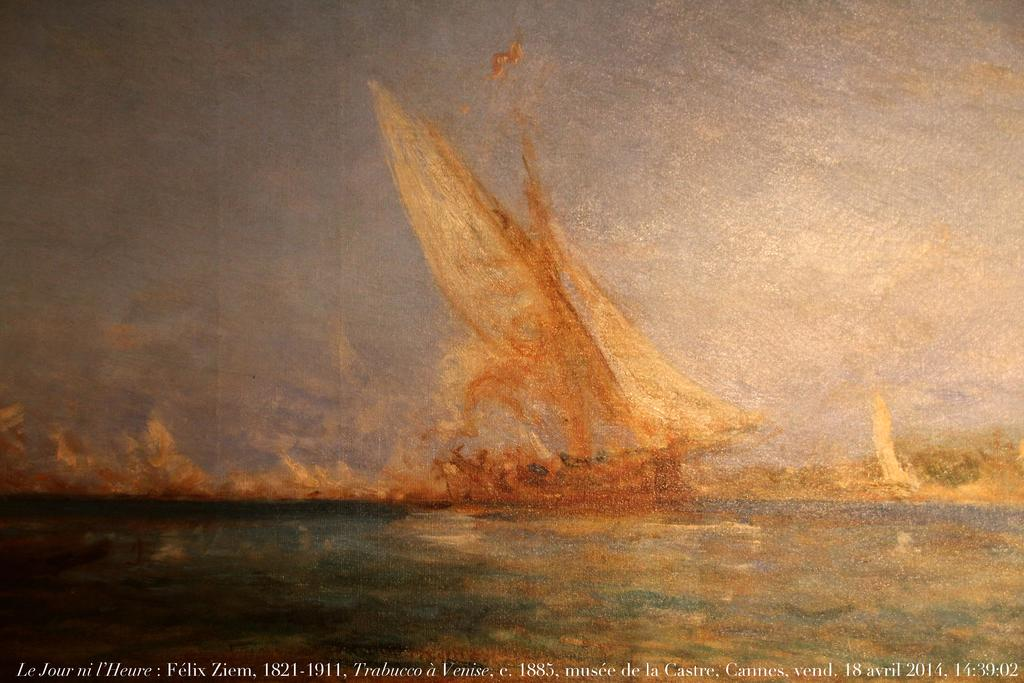<image>
Summarize the visual content of the image. The dates 1821-1911 are written at the bottom of a painting of boats. 